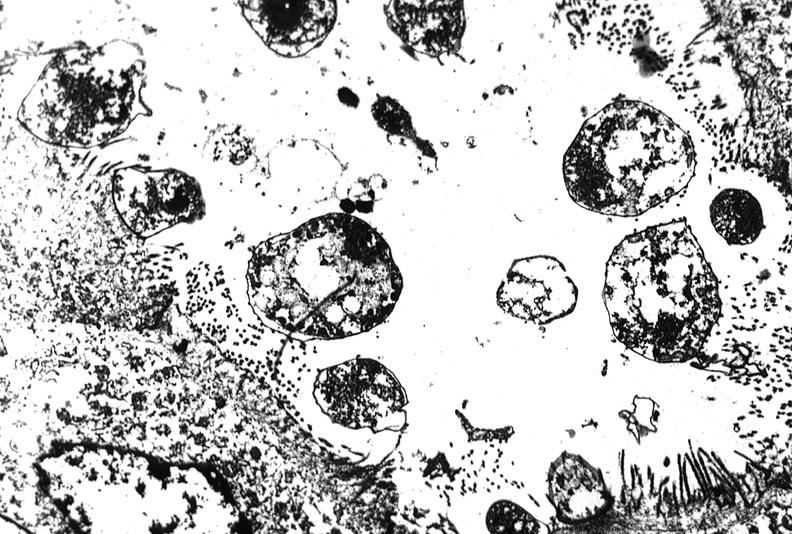does this image show colon biopsy, cryptosporidia?
Answer the question using a single word or phrase. Yes 